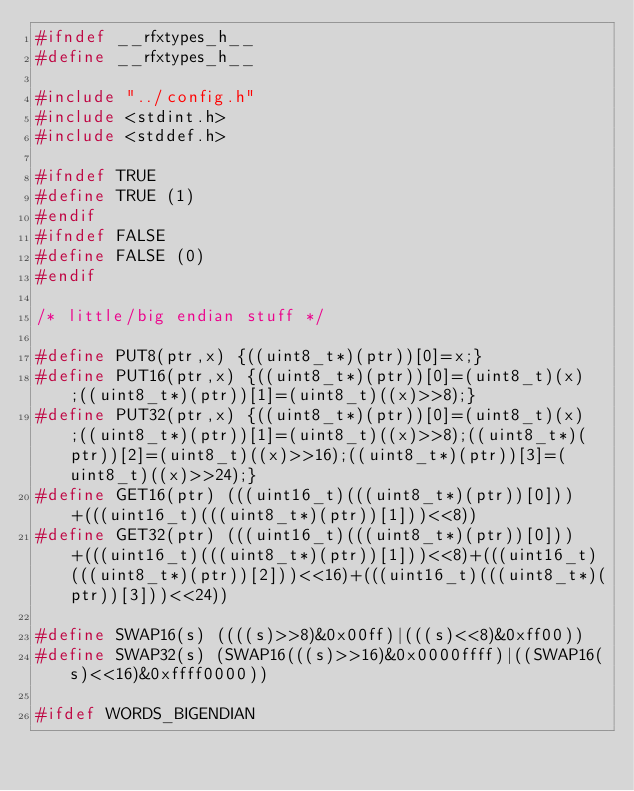<code> <loc_0><loc_0><loc_500><loc_500><_C_>#ifndef __rfxtypes_h__
#define __rfxtypes_h__

#include "../config.h"
#include <stdint.h>
#include <stddef.h>

#ifndef TRUE
#define TRUE (1)
#endif
#ifndef FALSE
#define FALSE (0)
#endif

/* little/big endian stuff */

#define PUT8(ptr,x) {((uint8_t*)(ptr))[0]=x;}
#define PUT16(ptr,x) {((uint8_t*)(ptr))[0]=(uint8_t)(x);((uint8_t*)(ptr))[1]=(uint8_t)((x)>>8);}
#define PUT32(ptr,x) {((uint8_t*)(ptr))[0]=(uint8_t)(x);((uint8_t*)(ptr))[1]=(uint8_t)((x)>>8);((uint8_t*)(ptr))[2]=(uint8_t)((x)>>16);((uint8_t*)(ptr))[3]=(uint8_t)((x)>>24);}
#define GET16(ptr) (((uint16_t)(((uint8_t*)(ptr))[0]))+(((uint16_t)(((uint8_t*)(ptr))[1]))<<8))
#define GET32(ptr) (((uint16_t)(((uint8_t*)(ptr))[0]))+(((uint16_t)(((uint8_t*)(ptr))[1]))<<8)+(((uint16_t)(((uint8_t*)(ptr))[2]))<<16)+(((uint16_t)(((uint8_t*)(ptr))[3]))<<24))

#define SWAP16(s) ((((s)>>8)&0x00ff)|(((s)<<8)&0xff00))
#define SWAP32(s) (SWAP16(((s)>>16)&0x0000ffff)|((SWAP16(s)<<16)&0xffff0000))

#ifdef WORDS_BIGENDIAN</code> 